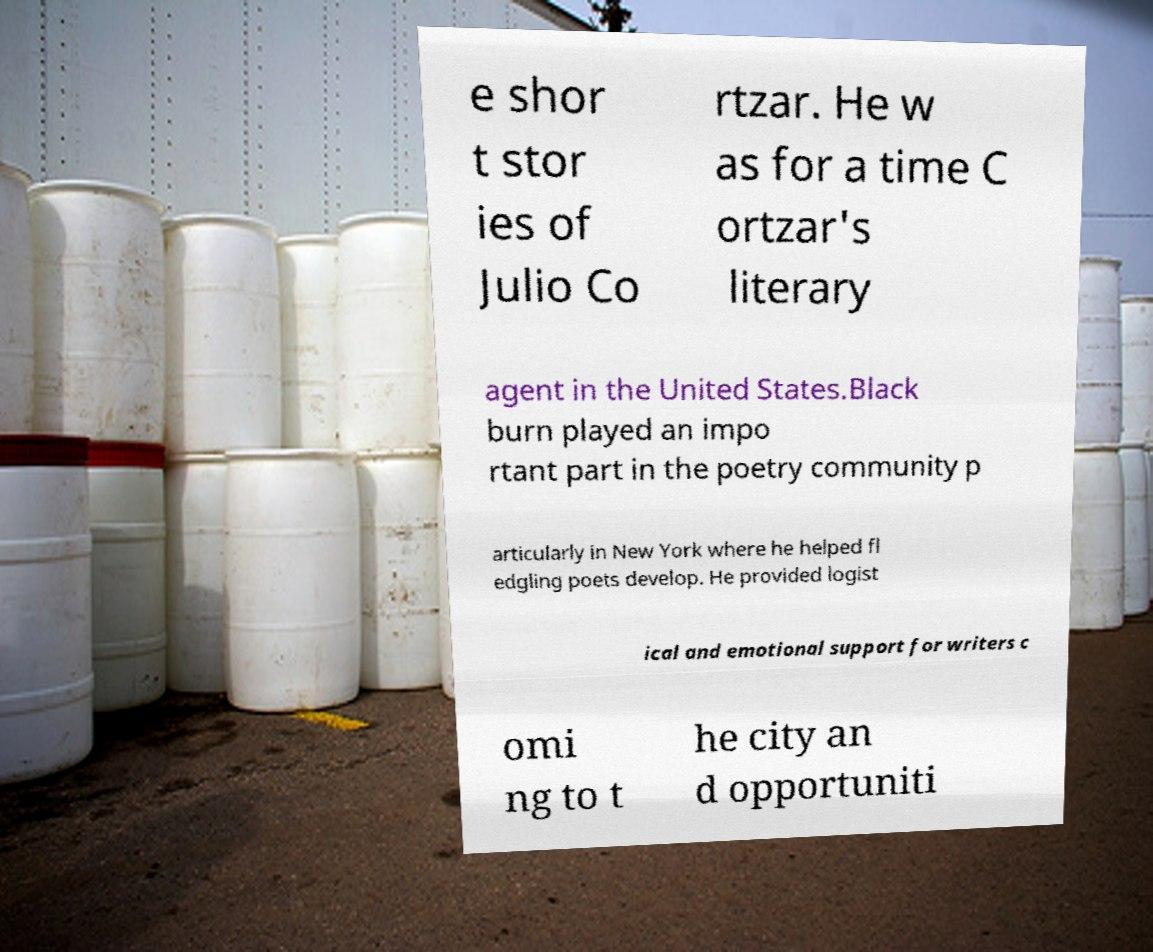Could you assist in decoding the text presented in this image and type it out clearly? e shor t stor ies of Julio Co rtzar. He w as for a time C ortzar's literary agent in the United States.Black burn played an impo rtant part in the poetry community p articularly in New York where he helped fl edgling poets develop. He provided logist ical and emotional support for writers c omi ng to t he city an d opportuniti 